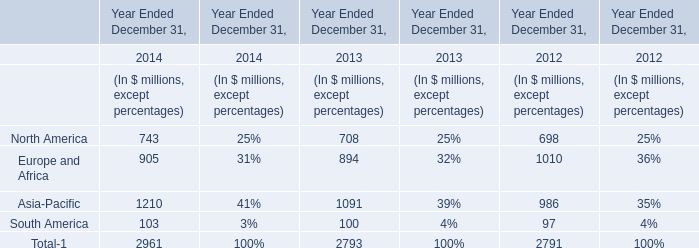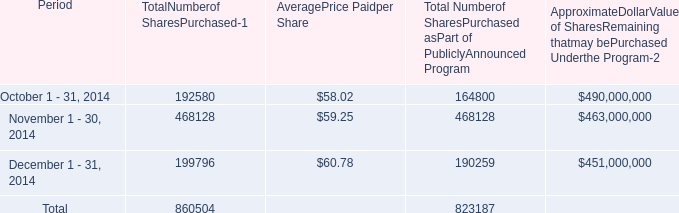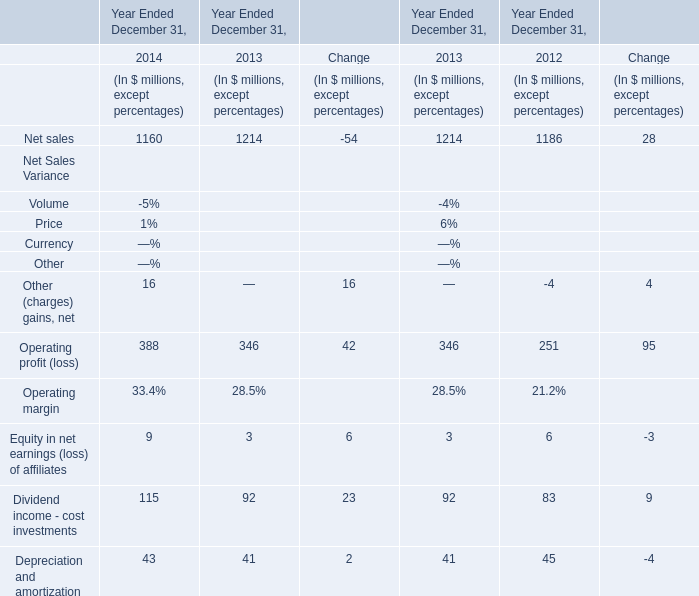in 2014 what was the percent of shares withheld from employees to cover their statutory minimum withholding requirements for personal income taxes to the shares purchased 
Computations: ((27780 + 9537) / 860504)
Answer: 0.04337. 